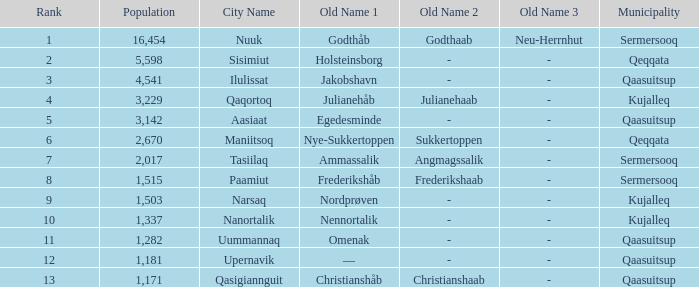What is the population for Rank 11? 1282.0. 